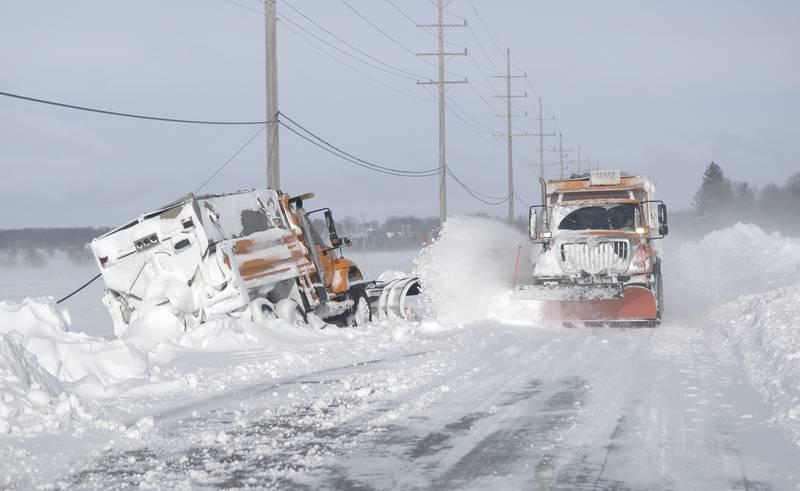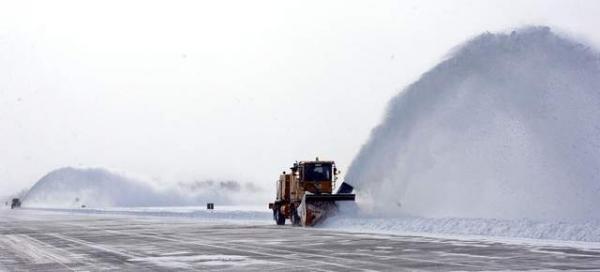The first image is the image on the left, the second image is the image on the right. Evaluate the accuracy of this statement regarding the images: "there are at least two vehicles in one of the images". Is it true? Answer yes or no. Yes. The first image is the image on the left, the second image is the image on the right. Assess this claim about the two images: "More than one snowplow truck is present on a snowy road.". Correct or not? Answer yes or no. Yes. 